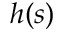<formula> <loc_0><loc_0><loc_500><loc_500>h ( s )</formula> 